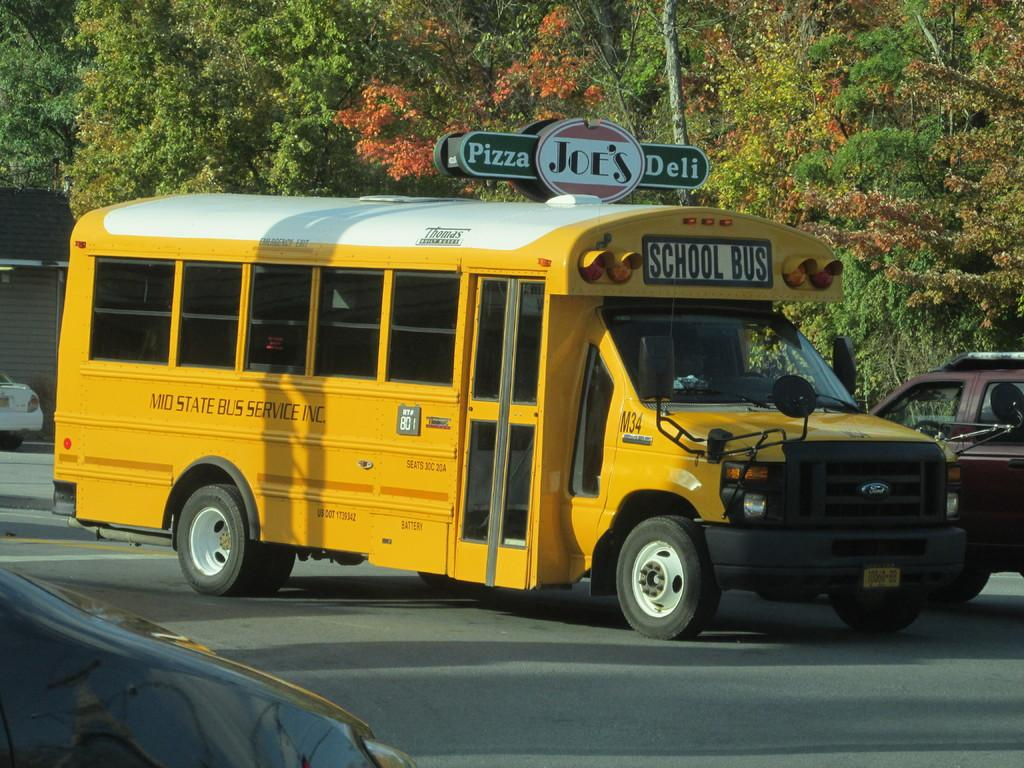<image>
Provide a brief description of the given image. A short yellow school bus drives down the road passing a pizza shop. 